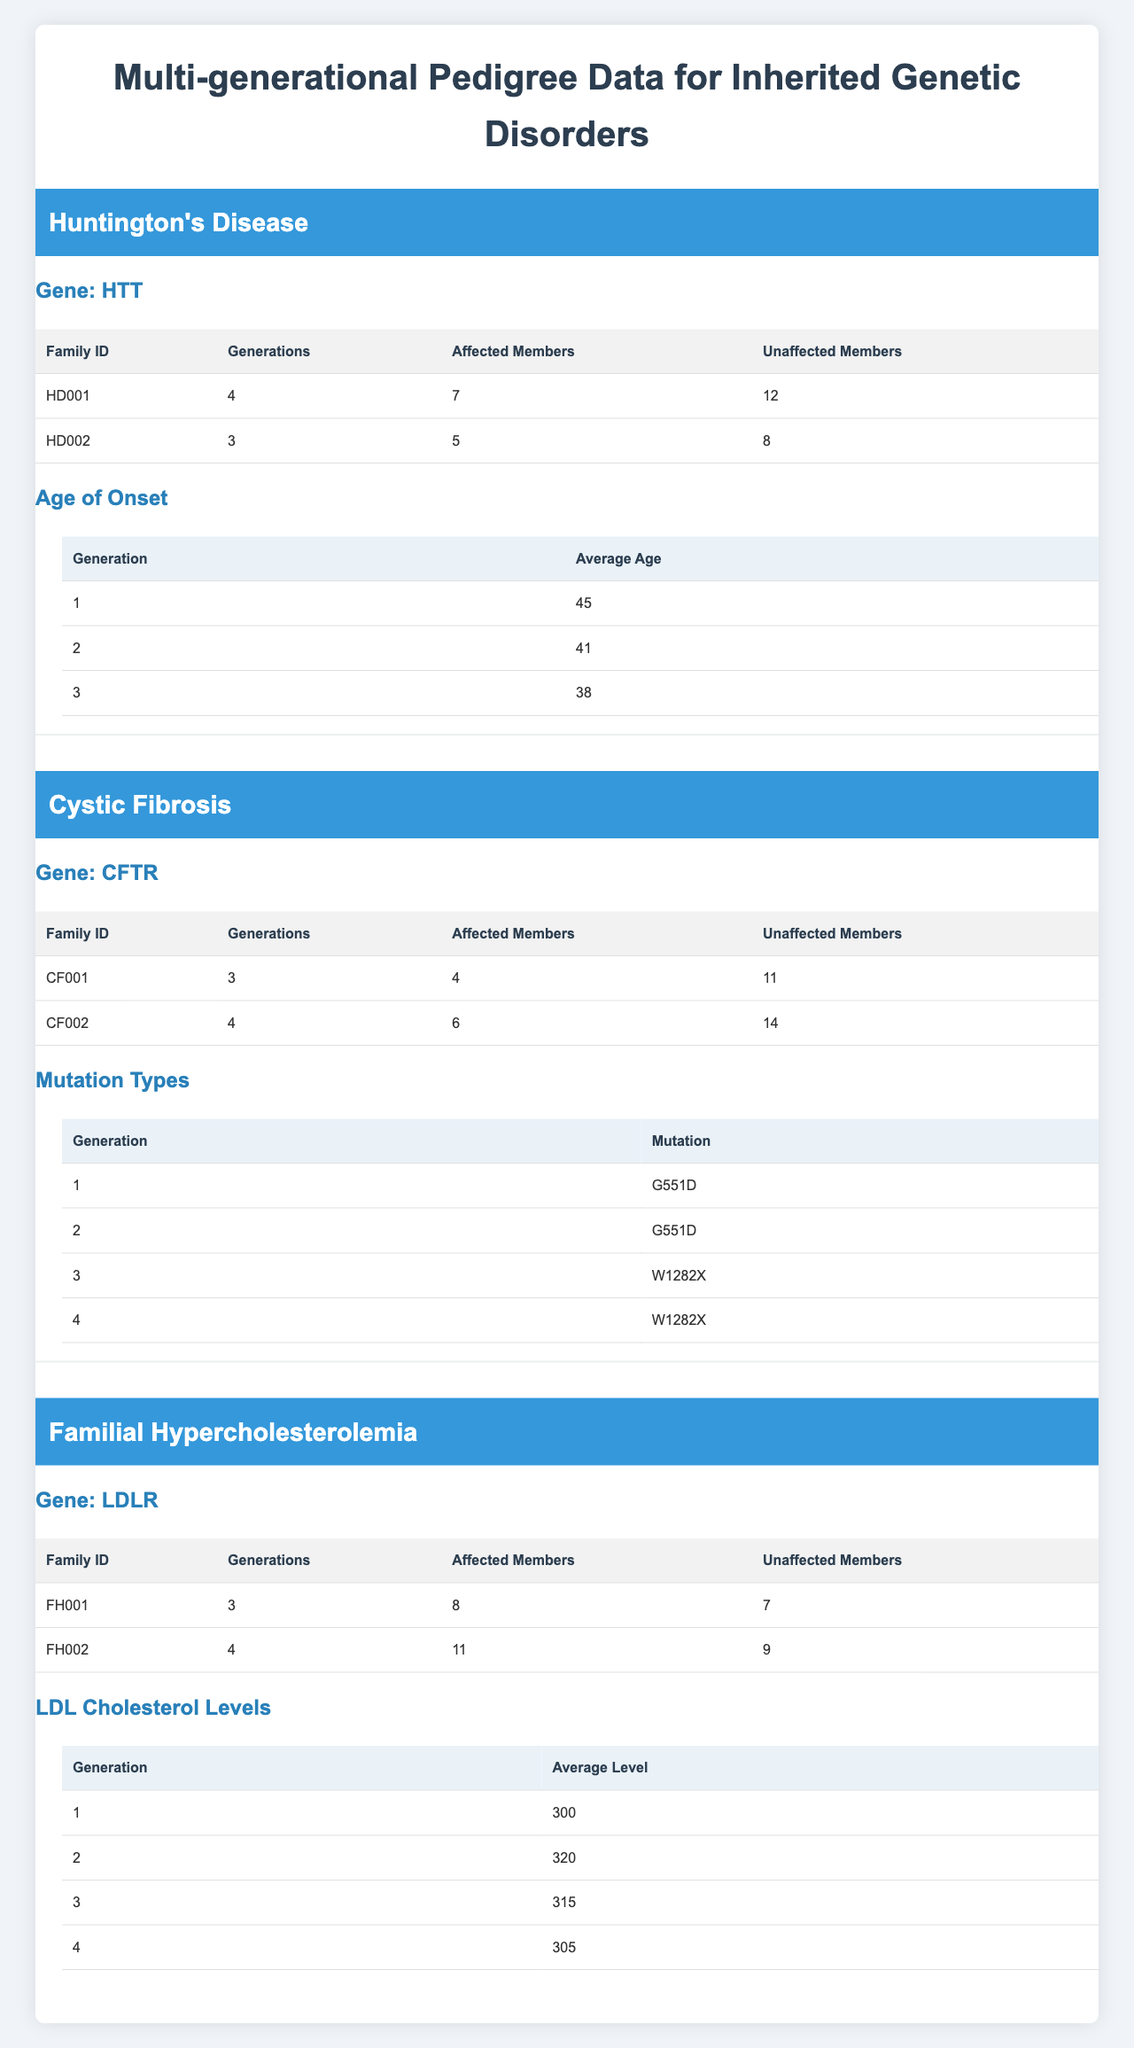What is the Family ID of the family with the highest number of affected members for Huntington's Disease? From the table, under Huntington's Disease, HD002 has 5 affected members, while HD001 has 7 affected members. Thus, the family with the highest number of affected members is HD001.
Answer: HD001 What is the average age of onset for the third generation affected by Huntington's Disease? The table shows that for Huntington's Disease, the average age of onset for the third generation is 36 years.
Answer: 36 How many unaffected members are in the family CF002 for Cystic Fibrosis? The table indicates that family CF002 has 14 unaffected members listed under Cystic Fibrosis.
Answer: 14 What is the average LDL cholesterol level for the second generation in Familial Hypercholesterolemia? According to the table, for Familial Hypercholesterolemia, the average LDL cholesterol level for the second generation is 320.
Answer: 320 Is the average age of onset for the first generation in Huntington's Disease less than 40? The average age of onset for the first generation in Huntington's Disease is 42, which is greater than 40, so the answer is no.
Answer: No What is the total number of affected members across all families under Cystic Fibrosis? Family CF001 has 4 affected members and family CF002 has 6 affected members. Adding them gives 4 + 6 = 10 affected members total.
Answer: 10 How much younger on average are the affected members in the fourth generation compared to the first generation in Huntington's Disease? The average age of onset for the first generation is 42 and for the fourth generation is 33. The difference is 42 - 33 = 9 years younger in the fourth generation.
Answer: 9 Which family has a mutation type 'W1282X' and in which generation does it appear? Family CF002 has a mutation type 'W1282X', which appears in both the third and fourth generations.
Answer: CF002, generations 3 and 4 Is the average LDL cholesterol level for the third generation in Familial Hypercholesterolemia greater than the average level for the first generation? The first generation has an average LDL cholesterol level of 285, while the third generation has an average level of 295. Therefore, yes, it is greater.
Answer: Yes What is the average affected family member count for all families listed under Familial Hypercholesterolemia? Family FH001 has 8 affected members and family FH002 has 11 affected members. To find the average, we sum them: 8 + 11 = 19, then divide by 2 (the number of families): 19 / 2 = 9.5.
Answer: 9.5 